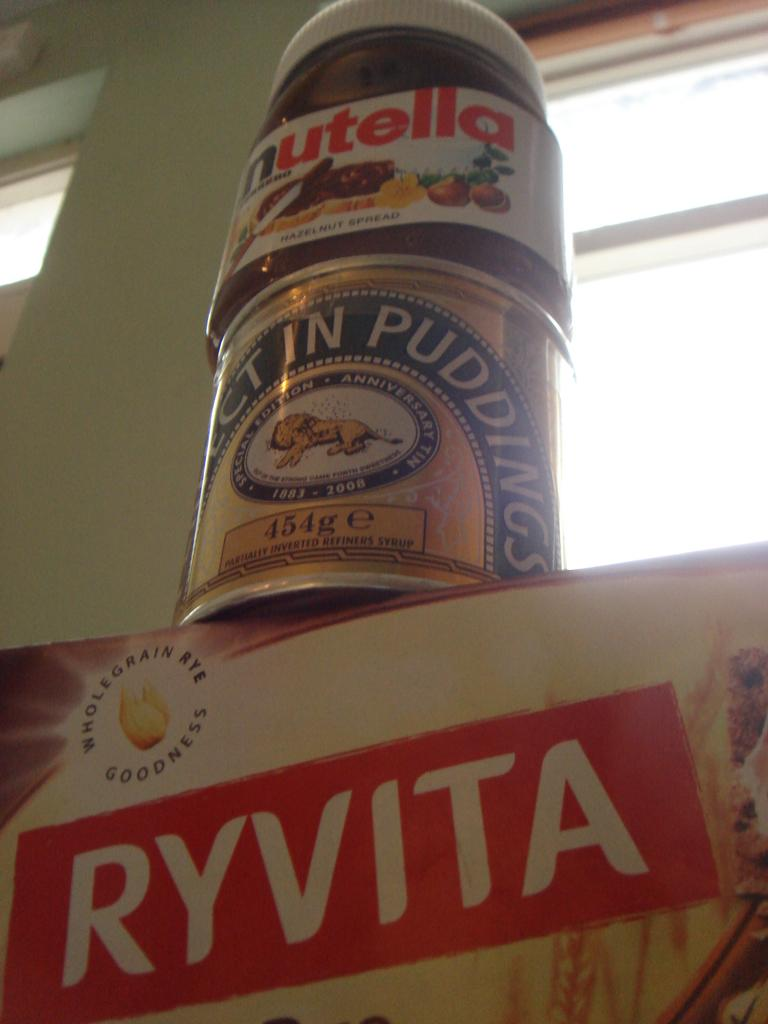<image>
Relay a brief, clear account of the picture shown. A can of nutella is on top of a can of pudding and a box that said Ryvita. 